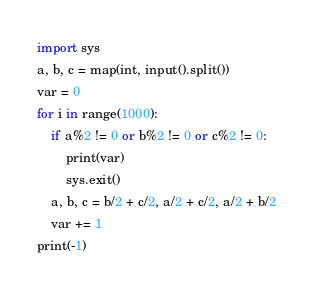Convert code to text. <code><loc_0><loc_0><loc_500><loc_500><_Python_>import sys
a, b, c = map(int, input().split())
var = 0
for i in range(1000):
    if a%2 != 0 or b%2 != 0 or c%2 != 0:
        print(var)
        sys.exit()
    a, b, c = b/2 + c/2, a/2 + c/2, a/2 + b/2
    var += 1
print(-1)</code> 